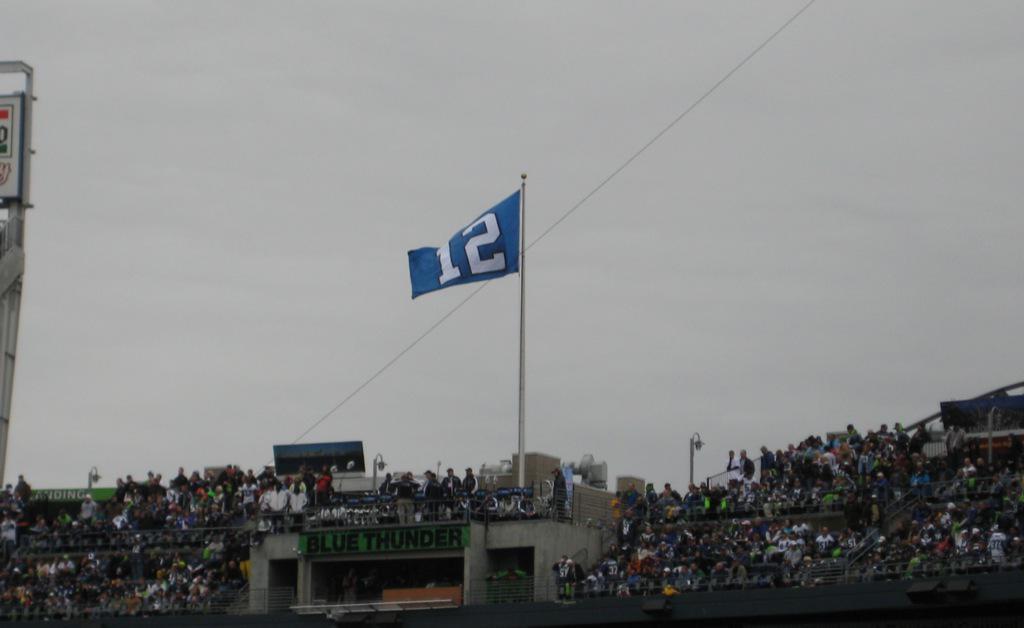Describe this image in one or two sentences. In this image we can see sky, flag, flag post, street light, tower and spectators sitting. 